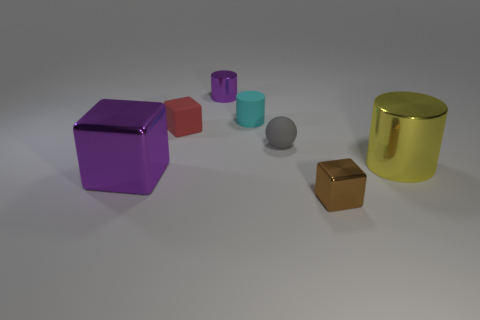There is a large thing that is the same color as the tiny shiny cylinder; what is its shape?
Offer a terse response. Cube. What is the color of the ball that is the same size as the rubber cylinder?
Provide a short and direct response. Gray. There is a matte cube; is its color the same as the cylinder that is right of the tiny metal block?
Offer a very short reply. No. What material is the purple thing that is to the left of the purple shiny thing behind the large yellow shiny cylinder?
Your answer should be very brief. Metal. How many objects are in front of the tiny gray thing and on the right side of the cyan cylinder?
Keep it short and to the point. 2. What number of other objects are there of the same size as the matte cylinder?
Make the answer very short. 4. Is the shape of the big object that is left of the tiny gray ball the same as the big metal thing that is on the right side of the small purple shiny object?
Your answer should be very brief. No. There is a gray thing; are there any big shiny things on the right side of it?
Your answer should be compact. Yes. What is the color of the small rubber object that is the same shape as the large purple thing?
Offer a terse response. Red. Are there any other things that have the same shape as the yellow shiny thing?
Offer a terse response. Yes. 